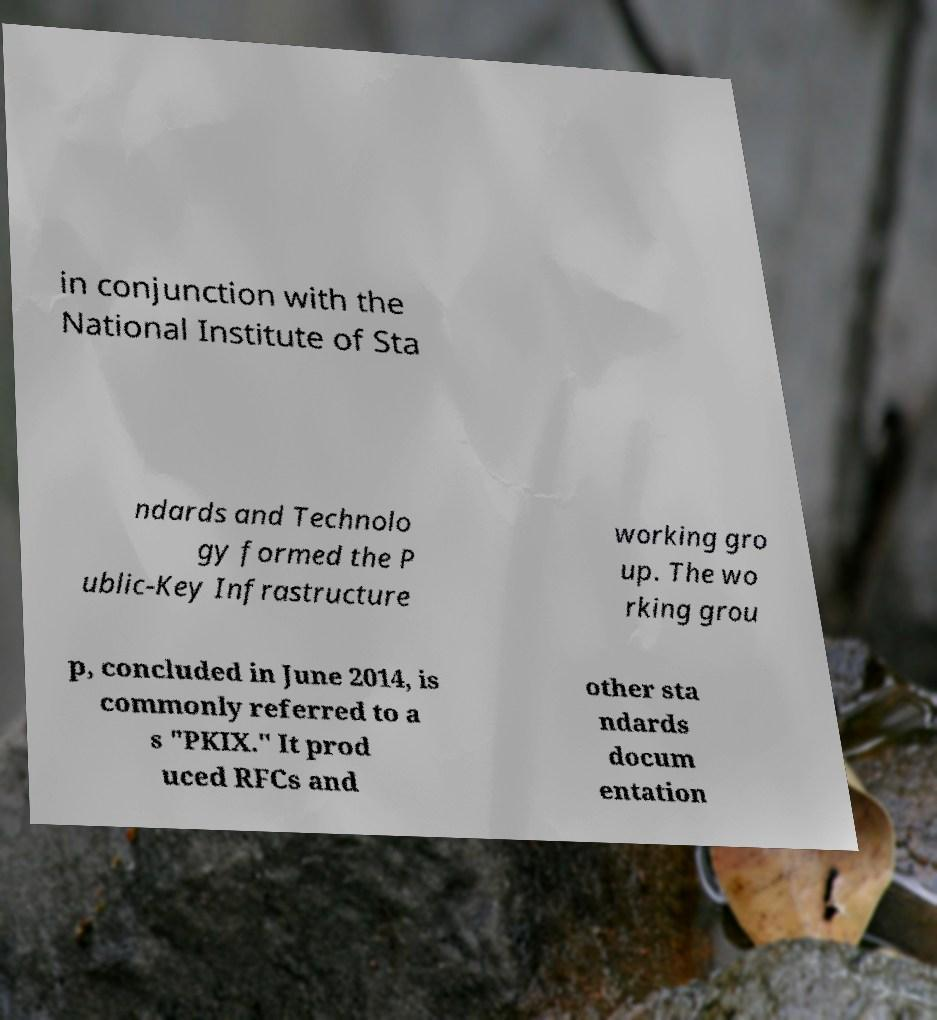Please read and relay the text visible in this image. What does it say? in conjunction with the National Institute of Sta ndards and Technolo gy formed the P ublic-Key Infrastructure working gro up. The wo rking grou p, concluded in June 2014, is commonly referred to a s "PKIX." It prod uced RFCs and other sta ndards docum entation 